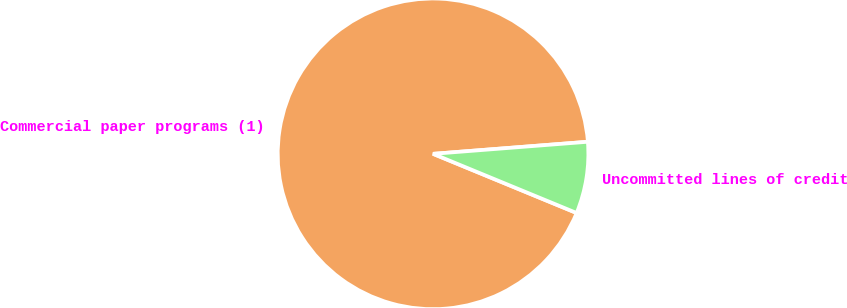<chart> <loc_0><loc_0><loc_500><loc_500><pie_chart><fcel>Commercial paper programs (1)<fcel>Uncommitted lines of credit<nl><fcel>92.54%<fcel>7.46%<nl></chart> 